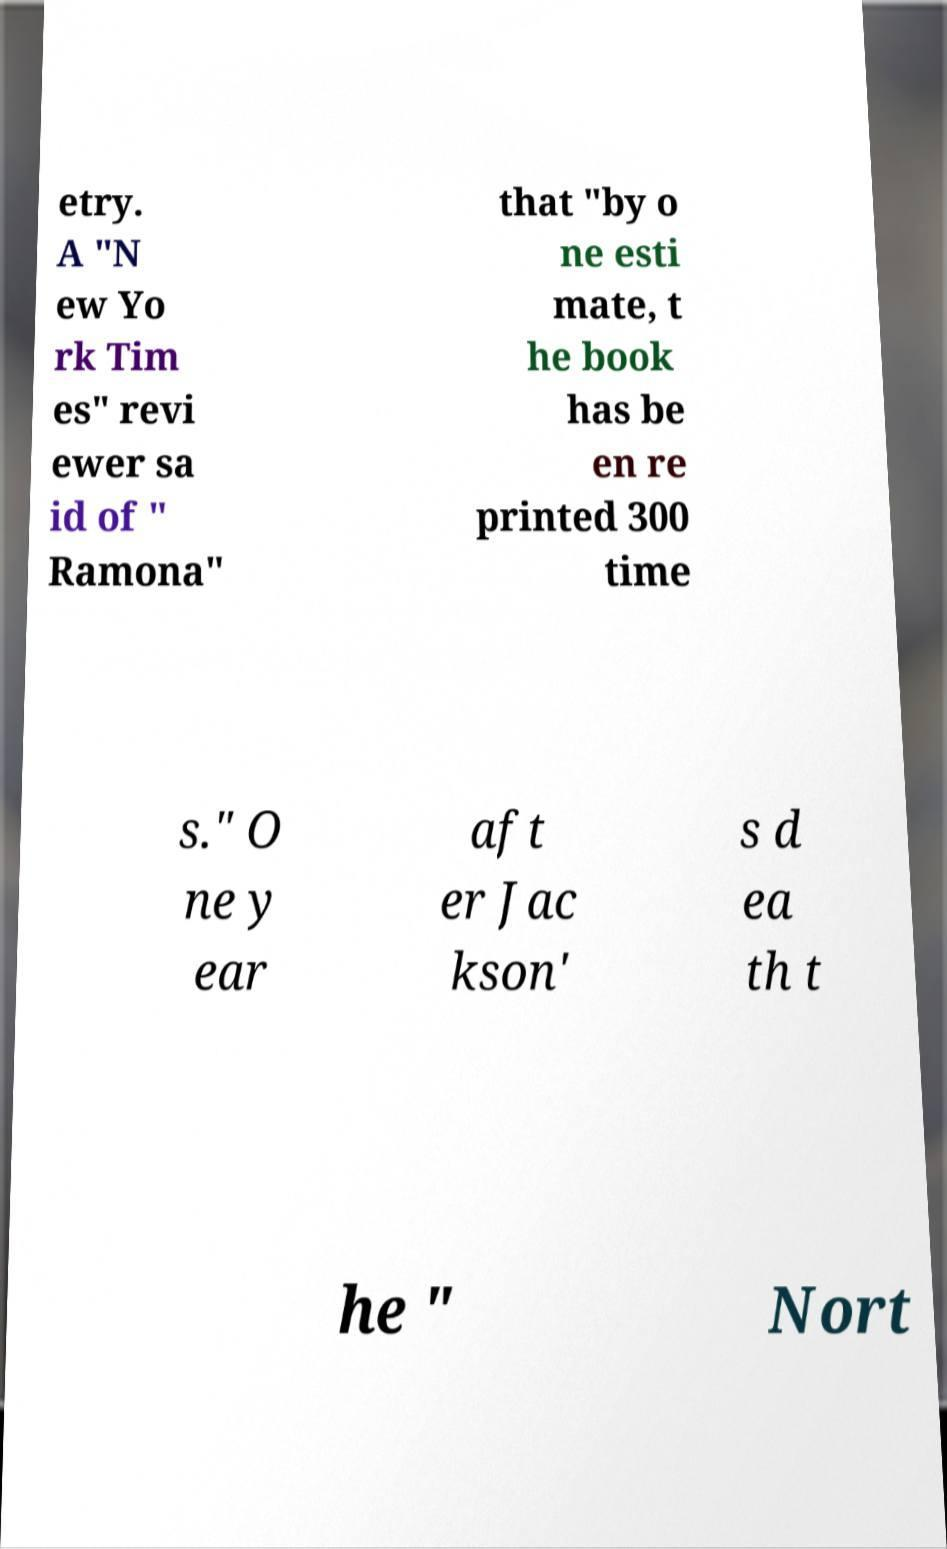Please identify and transcribe the text found in this image. etry. A "N ew Yo rk Tim es" revi ewer sa id of " Ramona" that "by o ne esti mate, t he book has be en re printed 300 time s." O ne y ear aft er Jac kson' s d ea th t he " Nort 